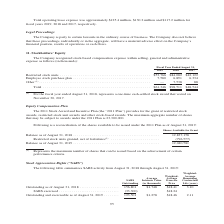According to Jabil Circuit's financial document, What were the restricted stock units in 2019? According to the financial document, $53,766 (in thousands). The relevant text states: "Restricted stock units . $53,766 $84,082 $42,122 Employee stock purchase plan . 7,580 6,891 6,334 Other (1) . — 7,538 88..." Also, What was the Employee stock purchase plan in 2018? According to the financial document, 6,891 (in thousands). The relevant text states: ",082 $42,122 Employee stock purchase plan . 7,580 6,891 6,334 Other (1) . — 7,538 88..." Also, What years does the table provide information for recognized stock-based compensation expense within selling, general and administrative expense for? The document contains multiple relevant values: 2019, 2018, 2017. From the document: "Fiscal Year Ended August 31, 2019 2018 2017 Fiscal Year Ended August 31, 2019 2018 2017 Fiscal Year Ended August 31, 2019 2018 2017..." Also, can you calculate: What was the change in Other stock-based compensation expenses between 2017 and 2018? Based on the calculation: 7,538-88, the result is 7450 (in thousands). This is based on the information: "hase plan . 7,580 6,891 6,334 Other (1) . — 7,538 88 k purchase plan . 7,580 6,891 6,334 Other (1) . — 7,538 88..." The key data points involved are: 7,538, 88. Also, can you calculate: What was the change in the restricted stock units between 2018 and 2019? Based on the calculation: $53,766-$84,082, the result is -30316 (in thousands). This is based on the information: "Restricted stock units . $53,766 $84,082 $42,122 Employee stock purchase plan . 7,580 6,891 6,334 Other (1) . — 7,538 88 Restricted stock units . $53,766 $84,082 $42,122 Employee stock purchase plan ...." The key data points involved are: 53,766, 84,082. Also, can you calculate: What was the percentage change in the total stock-based compensation expense between 2018 and 2019? To answer this question, I need to perform calculations using the financial data. The calculation is: ($61,346-$98,511)/$98,511, which equals -37.73 (percentage). This is based on the information: "Total . $61,346 $98,511 $48,544 Total . $61,346 $98,511 $48,544..." The key data points involved are: 61,346, 98,511. 